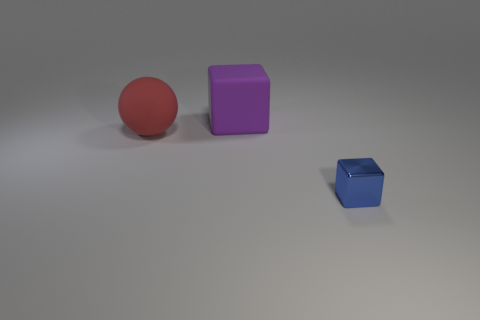Add 3 brown metallic objects. How many objects exist? 6 Subtract all spheres. How many objects are left? 2 Subtract all large objects. Subtract all large blue balls. How many objects are left? 1 Add 2 red objects. How many red objects are left? 3 Add 3 large rubber balls. How many large rubber balls exist? 4 Subtract 0 cyan blocks. How many objects are left? 3 